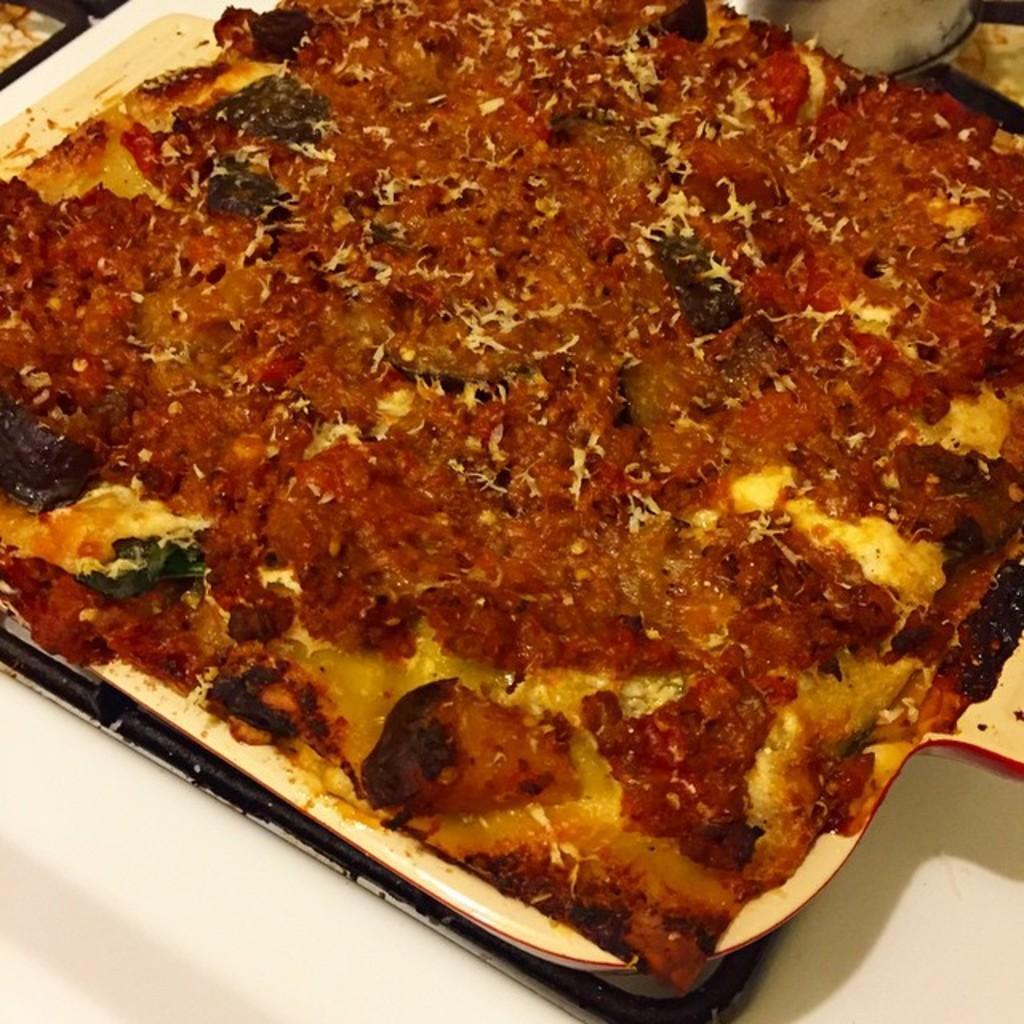Can you describe this image briefly? In the center of the image a food is present in the plate. 